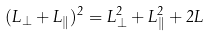Convert formula to latex. <formula><loc_0><loc_0><loc_500><loc_500>( L _ { \perp } + L _ { \| } ) ^ { 2 } = L _ { \perp } ^ { 2 } + L _ { \| } ^ { 2 } + 2 L</formula> 